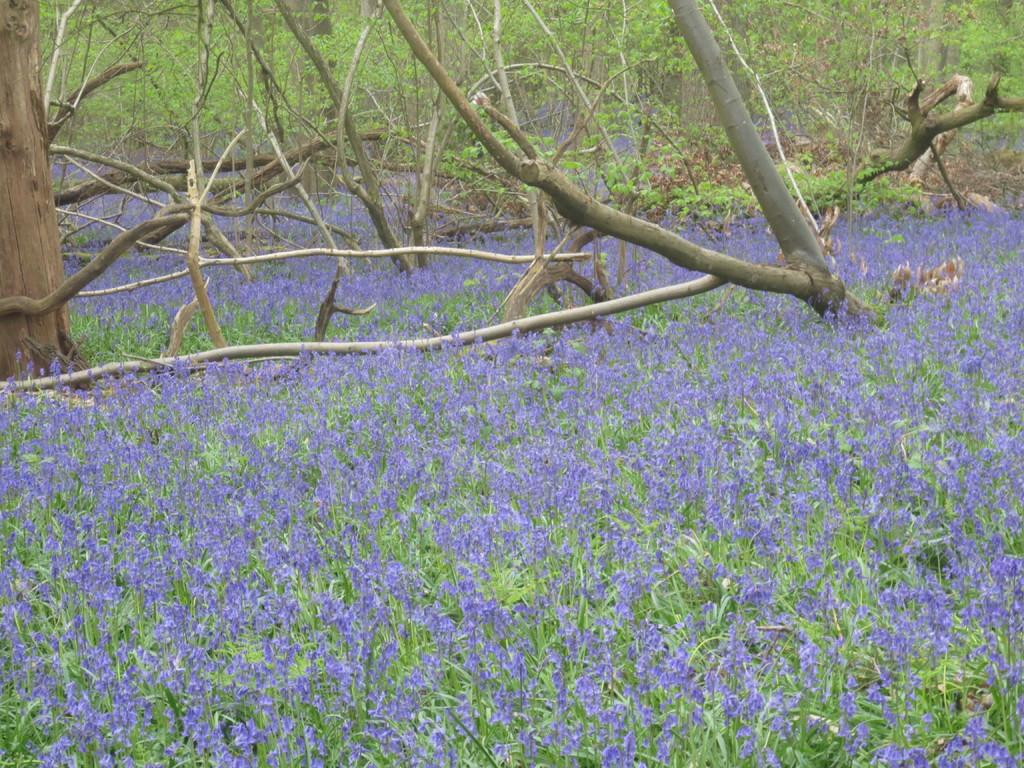What type of vegetation can be seen in the image? There are flowers, plants, and trees in the image. Can you describe the different types of vegetation present? The image contains flowers, which are smaller and more colorful, plants, which are typically green and leafy, and trees, which are larger and have a woody trunk. How many different types of vegetation are present in the image? There are three different types of vegetation present in the image: flowers, plants, and trees. How does the muscle in the image help the hill maintain its shape? There is no muscle or hill present in the image; it features flowers, plants, and trees. 